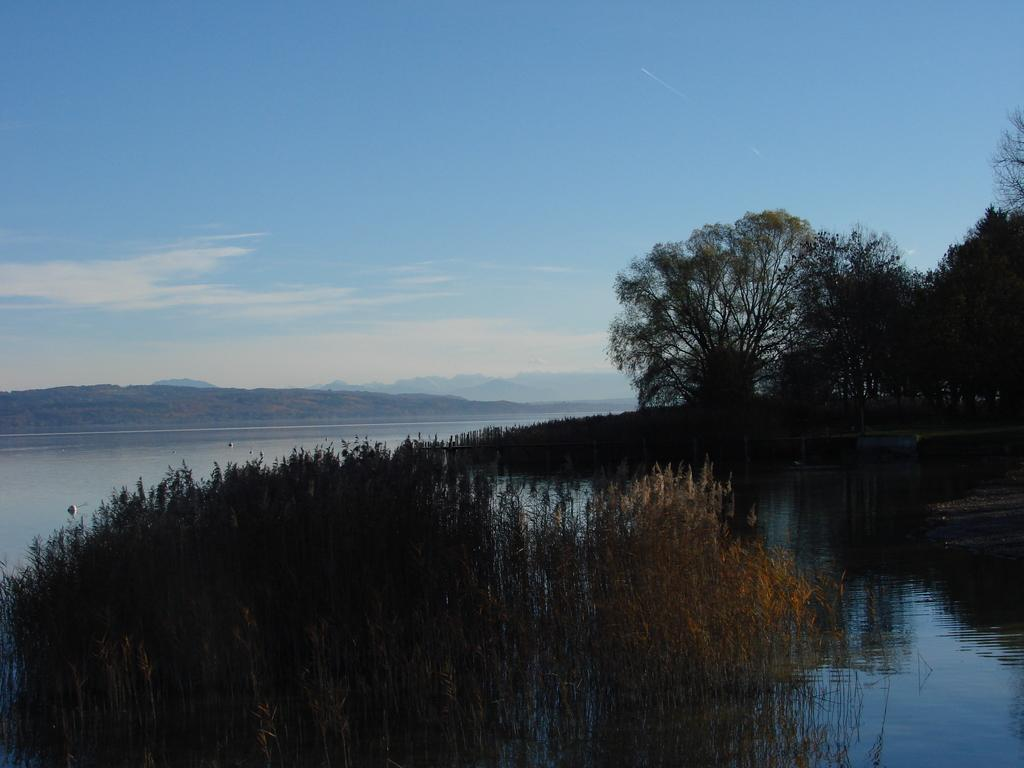What type of vegetation is present at the bottom of the image? There are trees at the bottom side of the image. What can be seen in the center of the image? There is water in the center of the image. What type of skirt is visible in the image? There is no skirt present in the image. What is being served for lunch in the image? There is no lunch or any food items visible in the image. 